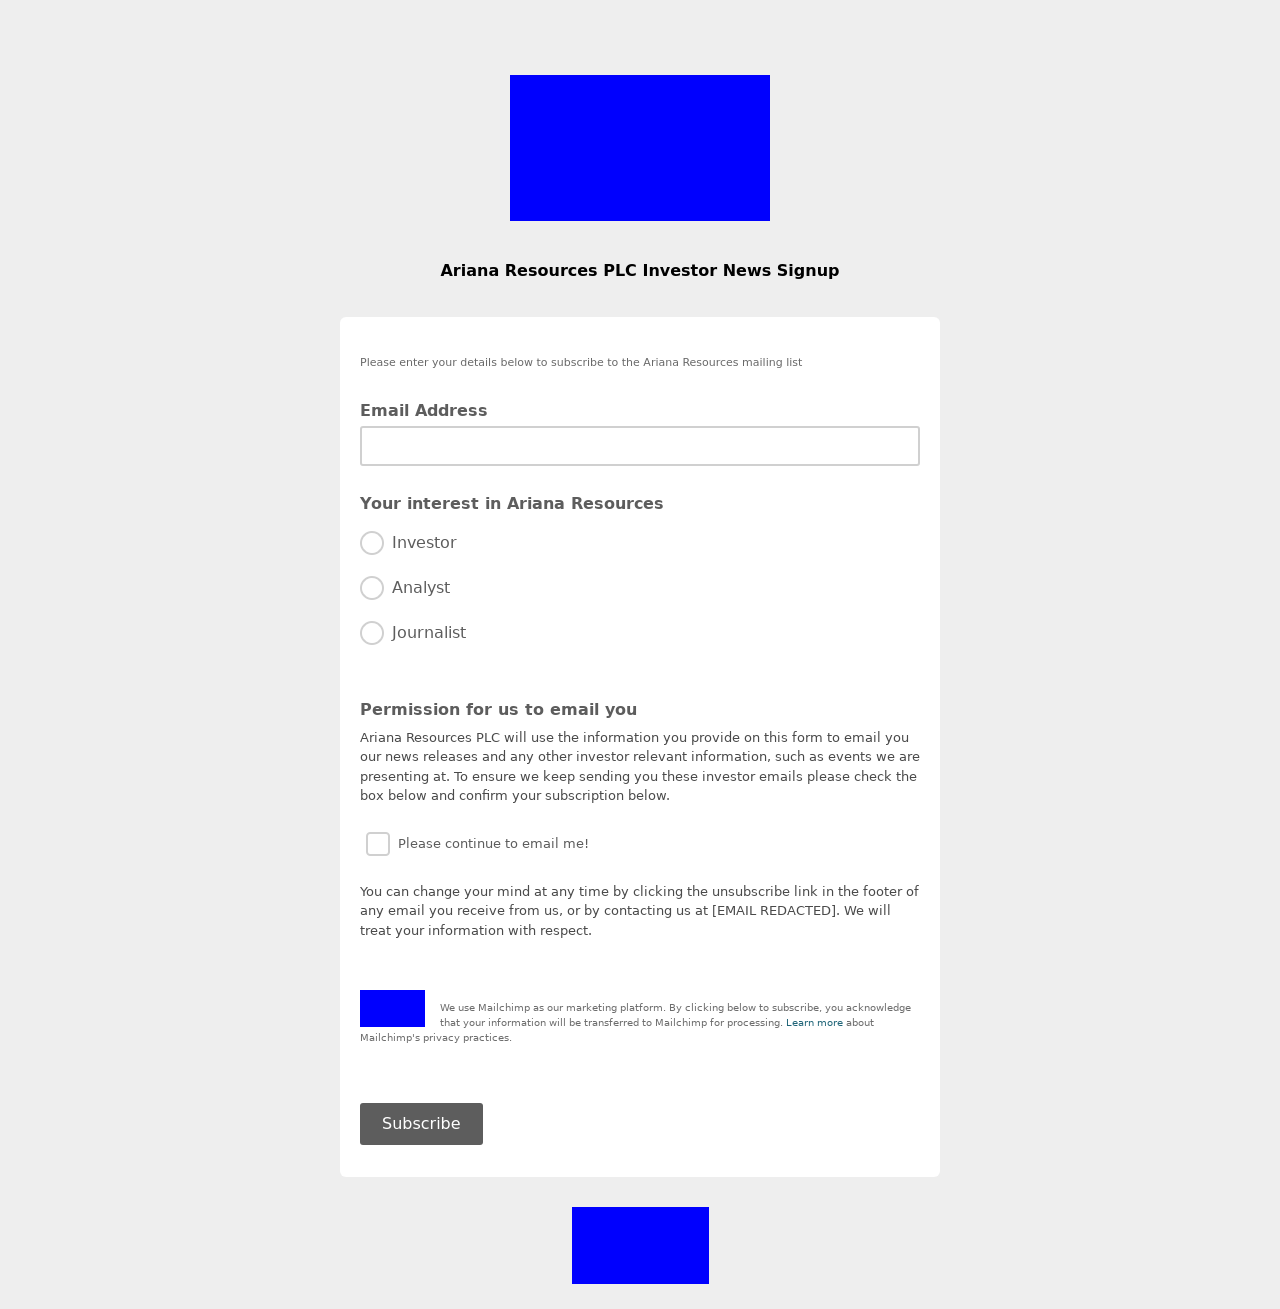What are the main components of this website's form as seen in the image? The main components of the form in the image include:
1. **Email Address Field**: A crucial component for users to enter their email addresses.
2. **Interest Options**: Radio buttons labeled 'Investor', 'Analyst', and 'Journalist' that allow users to specify their interest or relation to the content being offered.
3. **Permission Checkbox**: A box that users can check to give permission to send emails. It's a key part for GDPR compliance.
4. **Subscribe Button**: A button at the bottom to submit the form and complete the signup process. 